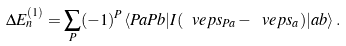Convert formula to latex. <formula><loc_0><loc_0><loc_500><loc_500>\Delta E _ { n } ^ { ( 1 ) } = \sum _ { P } ( - 1 ) ^ { P } \langle P a P b | I ( \ v e p s _ { P a } - \ v e p s _ { a } ) | a b \rangle \, .</formula> 